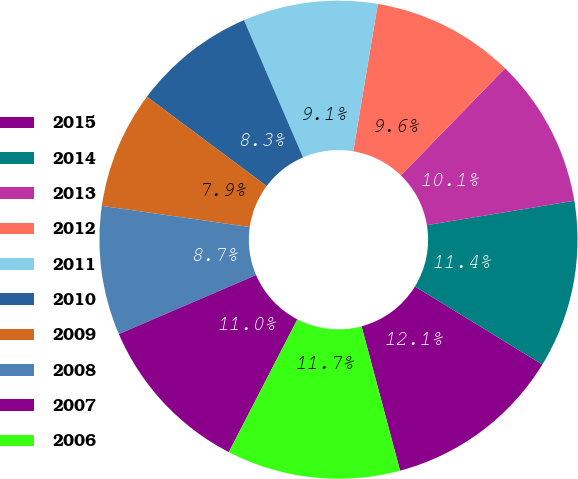Convert chart to OTSL. <chart><loc_0><loc_0><loc_500><loc_500><pie_chart><fcel>2015<fcel>2014<fcel>2013<fcel>2012<fcel>2011<fcel>2010<fcel>2009<fcel>2008<fcel>2007<fcel>2006<nl><fcel>12.11%<fcel>11.35%<fcel>10.12%<fcel>9.64%<fcel>9.1%<fcel>8.33%<fcel>7.94%<fcel>8.72%<fcel>10.96%<fcel>11.73%<nl></chart> 